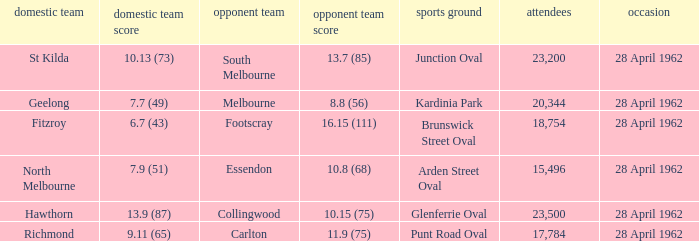What was the crowd size when there was a home team score of 10.13 (73)? 23200.0. Help me parse the entirety of this table. {'header': ['domestic team', 'domestic team score', 'opponent team', 'opponent team score', 'sports ground', 'attendees', 'occasion'], 'rows': [['St Kilda', '10.13 (73)', 'South Melbourne', '13.7 (85)', 'Junction Oval', '23,200', '28 April 1962'], ['Geelong', '7.7 (49)', 'Melbourne', '8.8 (56)', 'Kardinia Park', '20,344', '28 April 1962'], ['Fitzroy', '6.7 (43)', 'Footscray', '16.15 (111)', 'Brunswick Street Oval', '18,754', '28 April 1962'], ['North Melbourne', '7.9 (51)', 'Essendon', '10.8 (68)', 'Arden Street Oval', '15,496', '28 April 1962'], ['Hawthorn', '13.9 (87)', 'Collingwood', '10.15 (75)', 'Glenferrie Oval', '23,500', '28 April 1962'], ['Richmond', '9.11 (65)', 'Carlton', '11.9 (75)', 'Punt Road Oval', '17,784', '28 April 1962']]} 